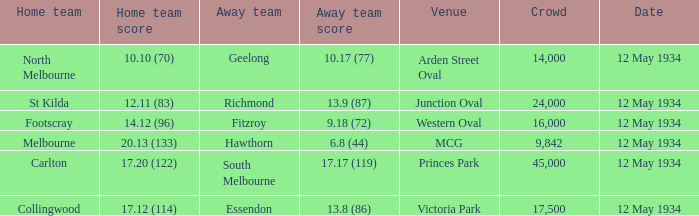What place had an Away team get a score of 10.17 (77)? Arden Street Oval. Parse the table in full. {'header': ['Home team', 'Home team score', 'Away team', 'Away team score', 'Venue', 'Crowd', 'Date'], 'rows': [['North Melbourne', '10.10 (70)', 'Geelong', '10.17 (77)', 'Arden Street Oval', '14,000', '12 May 1934'], ['St Kilda', '12.11 (83)', 'Richmond', '13.9 (87)', 'Junction Oval', '24,000', '12 May 1934'], ['Footscray', '14.12 (96)', 'Fitzroy', '9.18 (72)', 'Western Oval', '16,000', '12 May 1934'], ['Melbourne', '20.13 (133)', 'Hawthorn', '6.8 (44)', 'MCG', '9,842', '12 May 1934'], ['Carlton', '17.20 (122)', 'South Melbourne', '17.17 (119)', 'Princes Park', '45,000', '12 May 1934'], ['Collingwood', '17.12 (114)', 'Essendon', '13.8 (86)', 'Victoria Park', '17,500', '12 May 1934']]} 